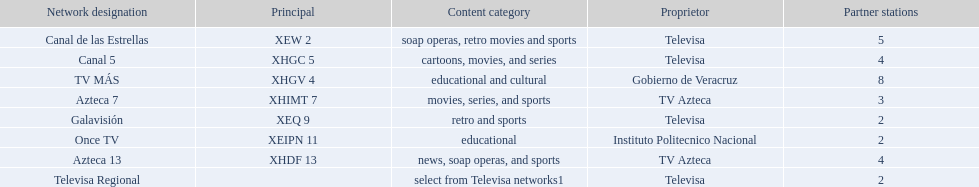Who has the most number of affiliates? TV MÁS. 